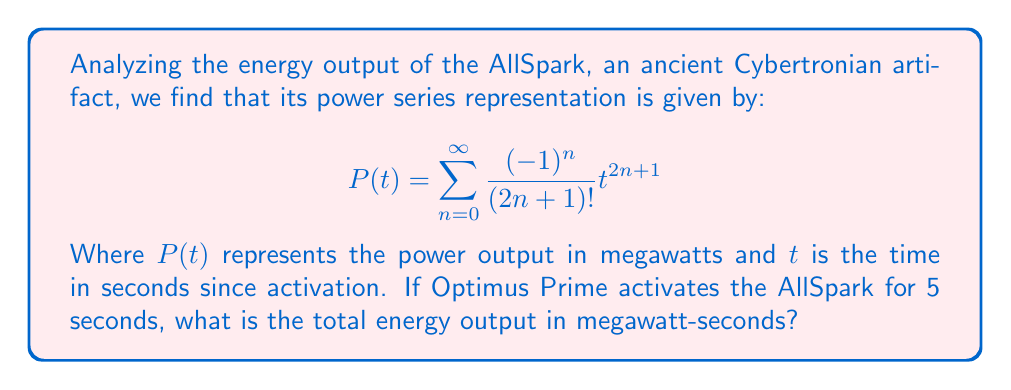Give your solution to this math problem. To solve this problem, we need to follow these steps:

1) First, we recognize that the given power series is actually the Taylor series for $\sin(t)$:

   $$\sin(t) = \sum_{n=0}^{\infty} \frac{(-1)^n}{(2n+1)!} t^{2n+1}$$

2) This means our power function $P(t) = \sin(t)$.

3) To find the total energy output, we need to integrate $P(t)$ from 0 to 5:

   $$E = \int_0^5 P(t) dt = \int_0^5 \sin(t) dt$$

4) We can solve this integral:

   $$\int_0^5 \sin(t) dt = [-\cos(t)]_0^5$$

5) Evaluating the integral:

   $$[-\cos(t)]_0^5 = -\cos(5) - (-\cos(0)) = -\cos(5) + 1$$

6) We can simplify this using a calculator or leaving it in this form.

   $$E = 1 - \cos(5)$$ megawatt-seconds
Answer: $1 - \cos(5)$ megawatt-seconds 